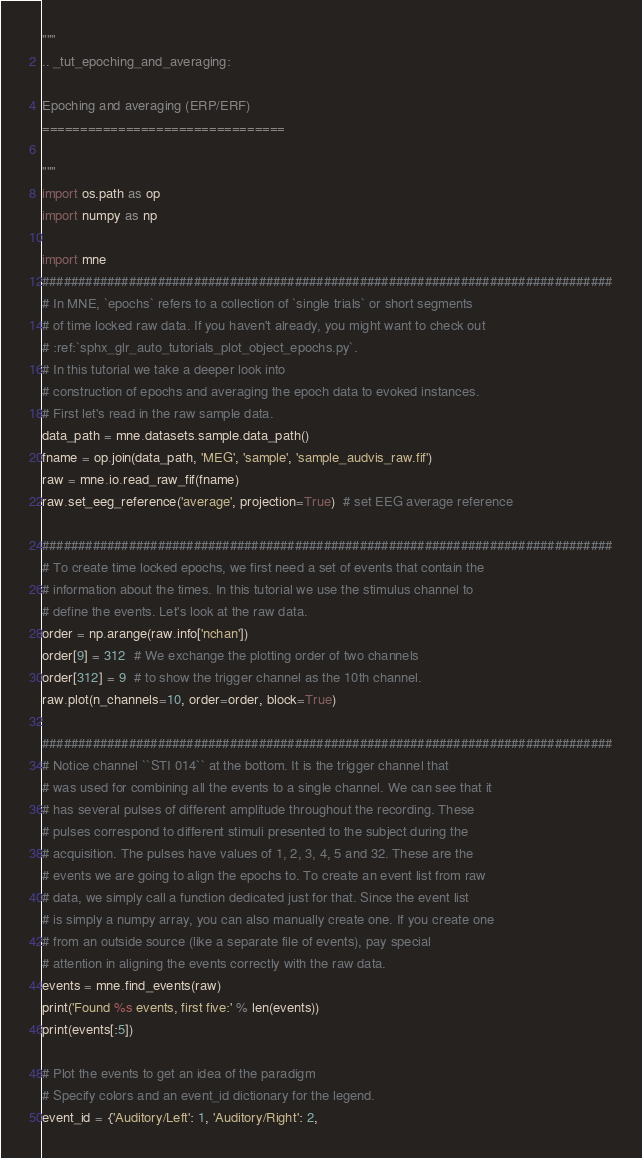Convert code to text. <code><loc_0><loc_0><loc_500><loc_500><_Python_>"""
.. _tut_epoching_and_averaging:

Epoching and averaging (ERP/ERF)
================================

"""
import os.path as op
import numpy as np

import mne
###############################################################################
# In MNE, `epochs` refers to a collection of `single trials` or short segments
# of time locked raw data. If you haven't already, you might want to check out
# :ref:`sphx_glr_auto_tutorials_plot_object_epochs.py`.
# In this tutorial we take a deeper look into
# construction of epochs and averaging the epoch data to evoked instances.
# First let's read in the raw sample data.
data_path = mne.datasets.sample.data_path()
fname = op.join(data_path, 'MEG', 'sample', 'sample_audvis_raw.fif')
raw = mne.io.read_raw_fif(fname)
raw.set_eeg_reference('average', projection=True)  # set EEG average reference

###############################################################################
# To create time locked epochs, we first need a set of events that contain the
# information about the times. In this tutorial we use the stimulus channel to
# define the events. Let's look at the raw data.
order = np.arange(raw.info['nchan'])
order[9] = 312  # We exchange the plotting order of two channels
order[312] = 9  # to show the trigger channel as the 10th channel.
raw.plot(n_channels=10, order=order, block=True)

###############################################################################
# Notice channel ``STI 014`` at the bottom. It is the trigger channel that
# was used for combining all the events to a single channel. We can see that it
# has several pulses of different amplitude throughout the recording. These
# pulses correspond to different stimuli presented to the subject during the
# acquisition. The pulses have values of 1, 2, 3, 4, 5 and 32. These are the
# events we are going to align the epochs to. To create an event list from raw
# data, we simply call a function dedicated just for that. Since the event list
# is simply a numpy array, you can also manually create one. If you create one
# from an outside source (like a separate file of events), pay special
# attention in aligning the events correctly with the raw data.
events = mne.find_events(raw)
print('Found %s events, first five:' % len(events))
print(events[:5])

# Plot the events to get an idea of the paradigm
# Specify colors and an event_id dictionary for the legend.
event_id = {'Auditory/Left': 1, 'Auditory/Right': 2,</code> 